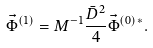Convert formula to latex. <formula><loc_0><loc_0><loc_500><loc_500>\vec { \Phi } ^ { ( 1 ) } = { M } ^ { - 1 } \frac { \bar { D } ^ { 2 } } { 4 } \vec { \Phi } ^ { ( 0 ) \, * } .</formula> 